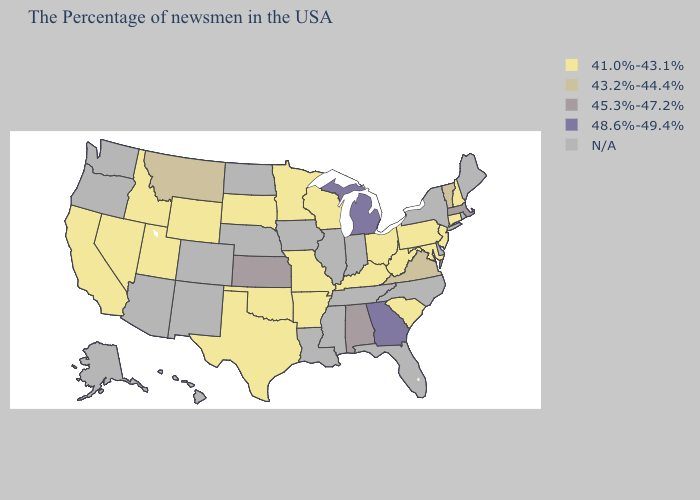What is the lowest value in the West?
Answer briefly. 41.0%-43.1%. Name the states that have a value in the range 45.3%-47.2%?
Concise answer only. Massachusetts, Alabama, Kansas. What is the value of Illinois?
Give a very brief answer. N/A. What is the value of Rhode Island?
Quick response, please. N/A. Among the states that border South Carolina , which have the lowest value?
Give a very brief answer. Georgia. Does Wyoming have the lowest value in the West?
Keep it brief. Yes. Does West Virginia have the lowest value in the South?
Concise answer only. Yes. Does the first symbol in the legend represent the smallest category?
Answer briefly. Yes. Name the states that have a value in the range 45.3%-47.2%?
Be succinct. Massachusetts, Alabama, Kansas. What is the value of Utah?
Quick response, please. 41.0%-43.1%. Does the map have missing data?
Give a very brief answer. Yes. Which states have the lowest value in the USA?
Give a very brief answer. New Hampshire, Connecticut, New Jersey, Maryland, Pennsylvania, South Carolina, West Virginia, Ohio, Kentucky, Wisconsin, Missouri, Arkansas, Minnesota, Oklahoma, Texas, South Dakota, Wyoming, Utah, Idaho, Nevada, California. Does New Jersey have the lowest value in the USA?
Be succinct. Yes. 